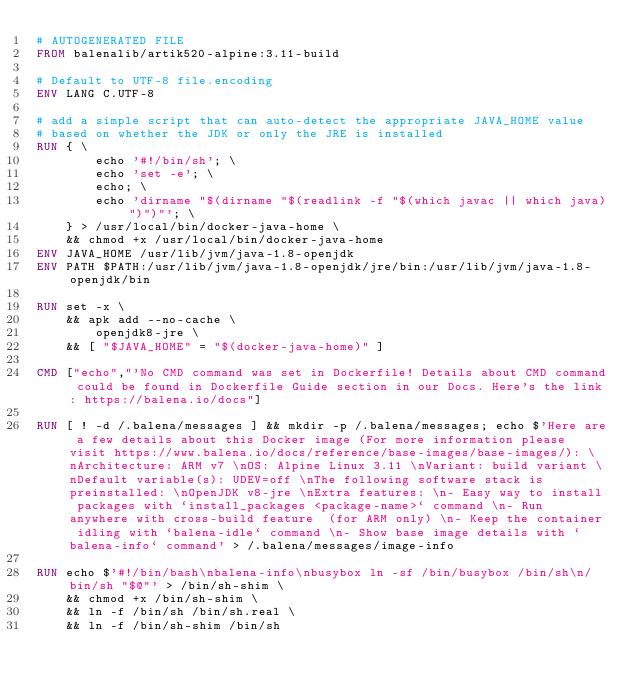Convert code to text. <code><loc_0><loc_0><loc_500><loc_500><_Dockerfile_># AUTOGENERATED FILE
FROM balenalib/artik520-alpine:3.11-build

# Default to UTF-8 file.encoding
ENV LANG C.UTF-8

# add a simple script that can auto-detect the appropriate JAVA_HOME value
# based on whether the JDK or only the JRE is installed
RUN { \
		echo '#!/bin/sh'; \
		echo 'set -e'; \
		echo; \
		echo 'dirname "$(dirname "$(readlink -f "$(which javac || which java)")")"'; \
	} > /usr/local/bin/docker-java-home \
	&& chmod +x /usr/local/bin/docker-java-home
ENV JAVA_HOME /usr/lib/jvm/java-1.8-openjdk
ENV PATH $PATH:/usr/lib/jvm/java-1.8-openjdk/jre/bin:/usr/lib/jvm/java-1.8-openjdk/bin

RUN set -x \
	&& apk add --no-cache \
		openjdk8-jre \
	&& [ "$JAVA_HOME" = "$(docker-java-home)" ]

CMD ["echo","'No CMD command was set in Dockerfile! Details about CMD command could be found in Dockerfile Guide section in our Docs. Here's the link: https://balena.io/docs"]

RUN [ ! -d /.balena/messages ] && mkdir -p /.balena/messages; echo $'Here are a few details about this Docker image (For more information please visit https://www.balena.io/docs/reference/base-images/base-images/): \nArchitecture: ARM v7 \nOS: Alpine Linux 3.11 \nVariant: build variant \nDefault variable(s): UDEV=off \nThe following software stack is preinstalled: \nOpenJDK v8-jre \nExtra features: \n- Easy way to install packages with `install_packages <package-name>` command \n- Run anywhere with cross-build feature  (for ARM only) \n- Keep the container idling with `balena-idle` command \n- Show base image details with `balena-info` command' > /.balena/messages/image-info

RUN echo $'#!/bin/bash\nbalena-info\nbusybox ln -sf /bin/busybox /bin/sh\n/bin/sh "$@"' > /bin/sh-shim \
	&& chmod +x /bin/sh-shim \
	&& ln -f /bin/sh /bin/sh.real \
	&& ln -f /bin/sh-shim /bin/sh</code> 